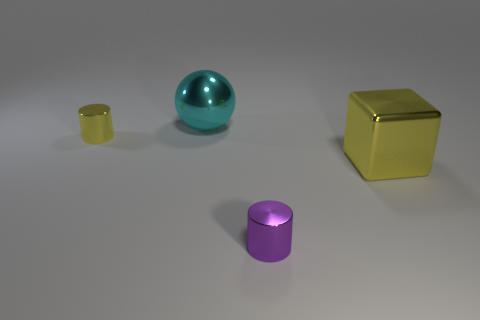There is a block; is its color the same as the shiny cylinder behind the large yellow metallic thing?
Provide a succinct answer. Yes. There is a thing that is to the left of the large yellow thing and in front of the small yellow metal cylinder; what size is it?
Your answer should be very brief. Small. What shape is the big yellow object that is the same material as the big cyan object?
Provide a succinct answer. Cube. There is a metal thing behind the tiny yellow object; is there a yellow shiny thing that is right of it?
Provide a succinct answer. Yes. There is a small cylinder in front of the cube; how many objects are on the left side of it?
Give a very brief answer. 2. Is there any other thing of the same color as the big metal block?
Provide a succinct answer. Yes. What number of things are cyan things or metallic cylinders that are to the right of the cyan object?
Offer a very short reply. 2. What is the material of the tiny cylinder left of the cylinder that is to the right of the large object to the left of the yellow block?
Make the answer very short. Metal. What size is the purple object that is made of the same material as the small yellow thing?
Provide a short and direct response. Small. There is a shiny cylinder that is in front of the yellow object on the left side of the ball; what color is it?
Your answer should be compact. Purple. 